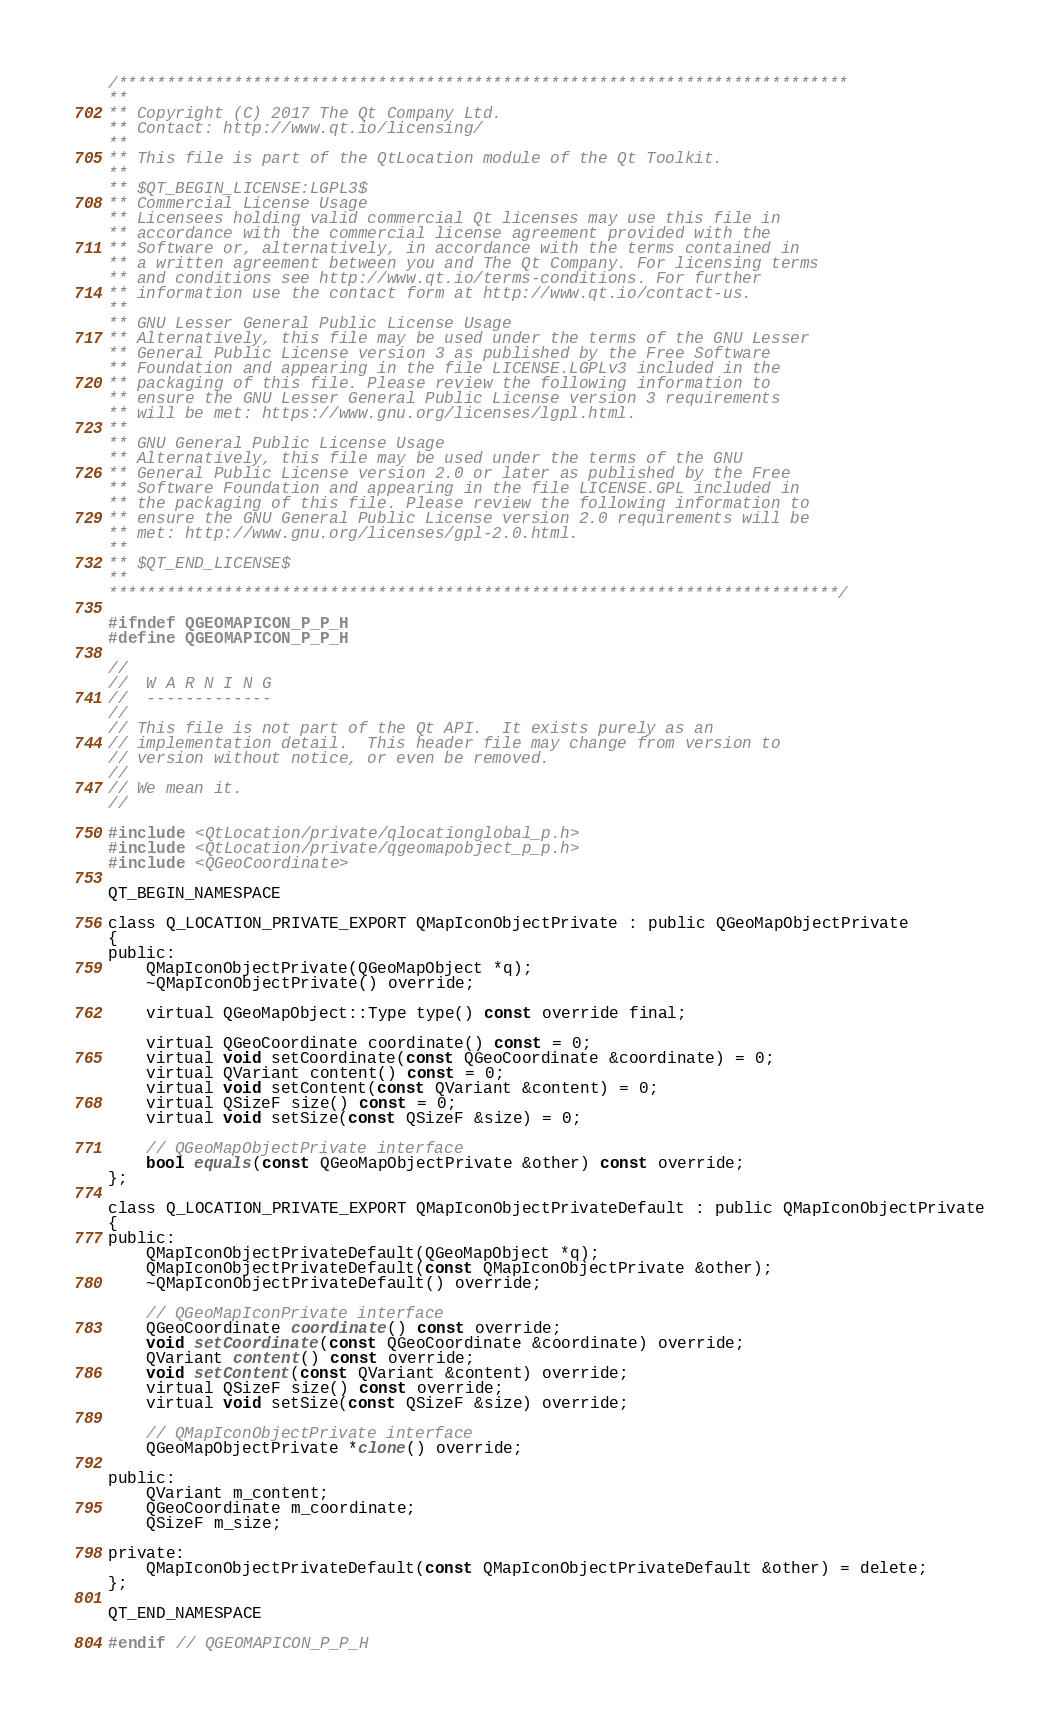<code> <loc_0><loc_0><loc_500><loc_500><_C_>/****************************************************************************
**
** Copyright (C) 2017 The Qt Company Ltd.
** Contact: http://www.qt.io/licensing/
**
** This file is part of the QtLocation module of the Qt Toolkit.
**
** $QT_BEGIN_LICENSE:LGPL3$
** Commercial License Usage
** Licensees holding valid commercial Qt licenses may use this file in
** accordance with the commercial license agreement provided with the
** Software or, alternatively, in accordance with the terms contained in
** a written agreement between you and The Qt Company. For licensing terms
** and conditions see http://www.qt.io/terms-conditions. For further
** information use the contact form at http://www.qt.io/contact-us.
**
** GNU Lesser General Public License Usage
** Alternatively, this file may be used under the terms of the GNU Lesser
** General Public License version 3 as published by the Free Software
** Foundation and appearing in the file LICENSE.LGPLv3 included in the
** packaging of this file. Please review the following information to
** ensure the GNU Lesser General Public License version 3 requirements
** will be met: https://www.gnu.org/licenses/lgpl.html.
**
** GNU General Public License Usage
** Alternatively, this file may be used under the terms of the GNU
** General Public License version 2.0 or later as published by the Free
** Software Foundation and appearing in the file LICENSE.GPL included in
** the packaging of this file. Please review the following information to
** ensure the GNU General Public License version 2.0 requirements will be
** met: http://www.gnu.org/licenses/gpl-2.0.html.
**
** $QT_END_LICENSE$
**
****************************************************************************/

#ifndef QGEOMAPICON_P_P_H
#define QGEOMAPICON_P_P_H

//
//  W A R N I N G
//  -------------
//
// This file is not part of the Qt API.  It exists purely as an
// implementation detail.  This header file may change from version to
// version without notice, or even be removed.
//
// We mean it.
//

#include <QtLocation/private/qlocationglobal_p.h>
#include <QtLocation/private/qgeomapobject_p_p.h>
#include <QGeoCoordinate>

QT_BEGIN_NAMESPACE

class Q_LOCATION_PRIVATE_EXPORT QMapIconObjectPrivate : public QGeoMapObjectPrivate
{
public:
    QMapIconObjectPrivate(QGeoMapObject *q);
    ~QMapIconObjectPrivate() override;

    virtual QGeoMapObject::Type type() const override final;

    virtual QGeoCoordinate coordinate() const = 0;
    virtual void setCoordinate(const QGeoCoordinate &coordinate) = 0;
    virtual QVariant content() const = 0;
    virtual void setContent(const QVariant &content) = 0;
    virtual QSizeF size() const = 0;
    virtual void setSize(const QSizeF &size) = 0;

    // QGeoMapObjectPrivate interface
    bool equals(const QGeoMapObjectPrivate &other) const override;
};

class Q_LOCATION_PRIVATE_EXPORT QMapIconObjectPrivateDefault : public QMapIconObjectPrivate
{
public:
    QMapIconObjectPrivateDefault(QGeoMapObject *q);
    QMapIconObjectPrivateDefault(const QMapIconObjectPrivate &other);
    ~QMapIconObjectPrivateDefault() override;

    // QGeoMapIconPrivate interface
    QGeoCoordinate coordinate() const override;
    void setCoordinate(const QGeoCoordinate &coordinate) override;
    QVariant content() const override;
    void setContent(const QVariant &content) override;
    virtual QSizeF size() const override;
    virtual void setSize(const QSizeF &size) override;

    // QMapIconObjectPrivate interface
    QGeoMapObjectPrivate *clone() override;

public:
    QVariant m_content;
    QGeoCoordinate m_coordinate;
    QSizeF m_size;

private:
    QMapIconObjectPrivateDefault(const QMapIconObjectPrivateDefault &other) = delete;
};

QT_END_NAMESPACE

#endif // QGEOMAPICON_P_P_H
</code> 